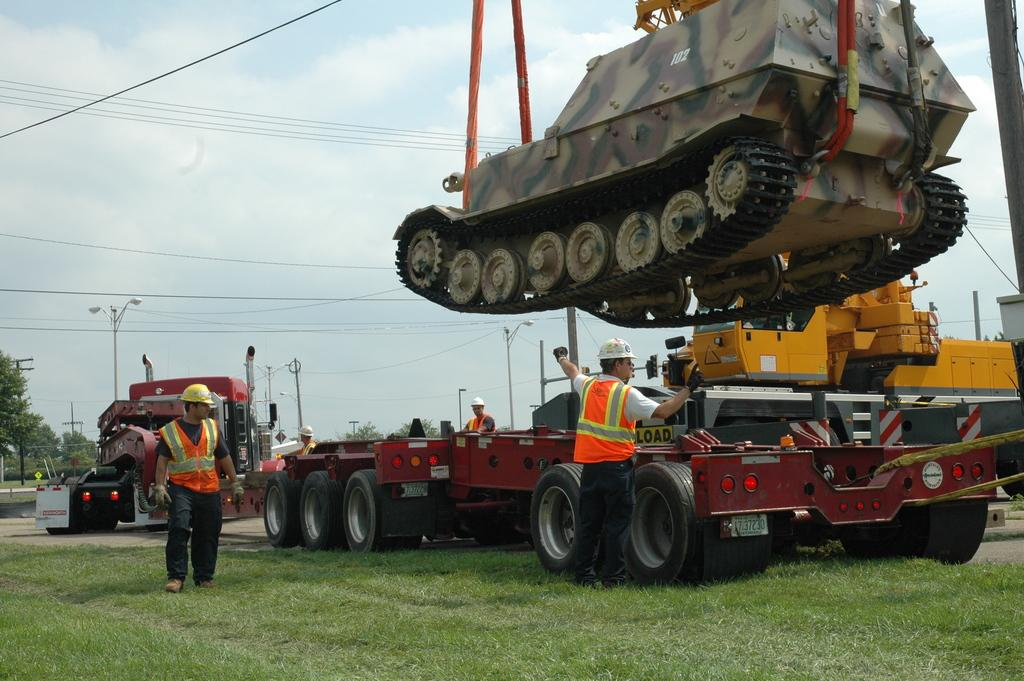What type of vegetation can be seen in the image? There is grass in the image. What types of vehicles are present in the image? There are vehicles in the image. What specific vehicle can be seen in the image? There is a tank in the image. Can you describe the people in the image? There are people in the image, and they are wearing jackets and helmets. What structures can be seen in the image? There are poles in the image. What is attached to the poles? There are lights in the image, and they are attached to the poles. What else can be seen in the image? There are wires, trees, clouds, and the sky visible in the image. What type of sweater is your dad wearing in the image? There is no reference to a dad or a sweater in the image, so it is not possible to answer that question. 